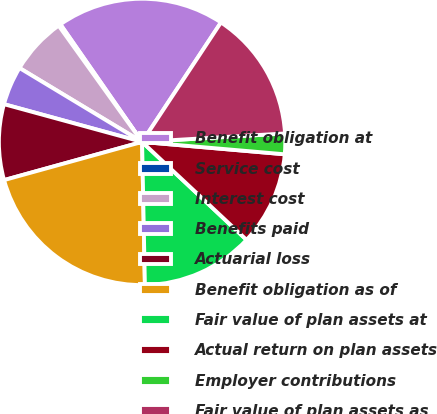<chart> <loc_0><loc_0><loc_500><loc_500><pie_chart><fcel>Benefit obligation at<fcel>Service cost<fcel>Interest cost<fcel>Benefits paid<fcel>Actuarial loss<fcel>Benefit obligation as of<fcel>Fair value of plan assets at<fcel>Actual return on plan assets<fcel>Employer contributions<fcel>Fair value of plan assets as<nl><fcel>18.95%<fcel>0.24%<fcel>6.46%<fcel>4.39%<fcel>8.54%<fcel>21.02%<fcel>12.7%<fcel>10.61%<fcel>2.32%<fcel>14.77%<nl></chart> 